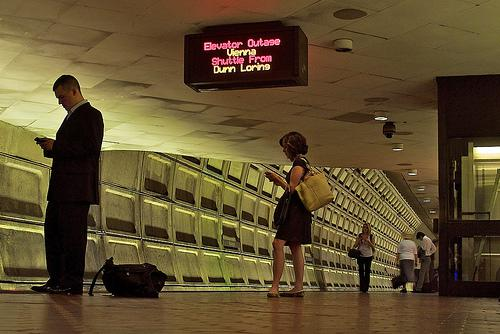Question: why is the man looking down?
Choices:
A. Ipad.
B. Book.
C. Phone.
D. Newspaper.
Answer with the letter. Answer: C Question: what color is the word Vienna?
Choices:
A. Yellow.
B. Black.
C. White.
D. Brown.
Answer with the letter. Answer: A Question: what color is the closest woman's purse?
Choices:
A. Tan.
B. Yellow.
C. Orange.
D. Blue.
Answer with the letter. Answer: A Question: what is on the ground behind the man?
Choices:
A. Baggage.
B. Trash.
C. Cat.
D. Child.
Answer with the letter. Answer: A 